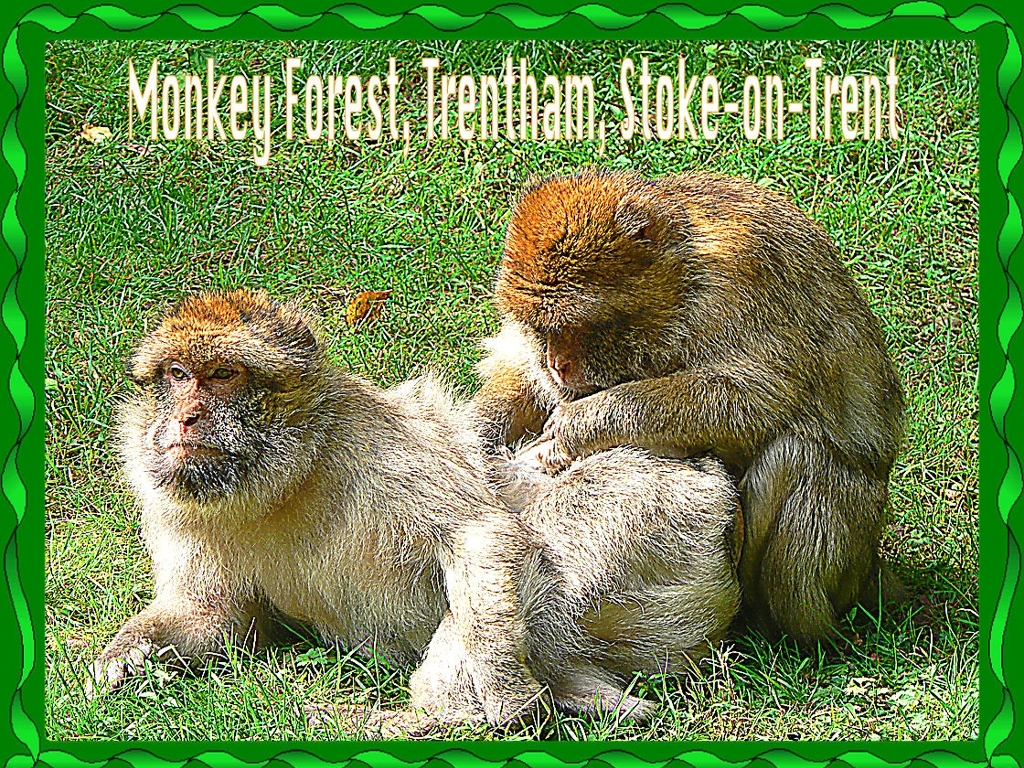Is there any noise in this image?
A. Yes
B. No
Answer with the option's letter from the given choices directly.
 B. 